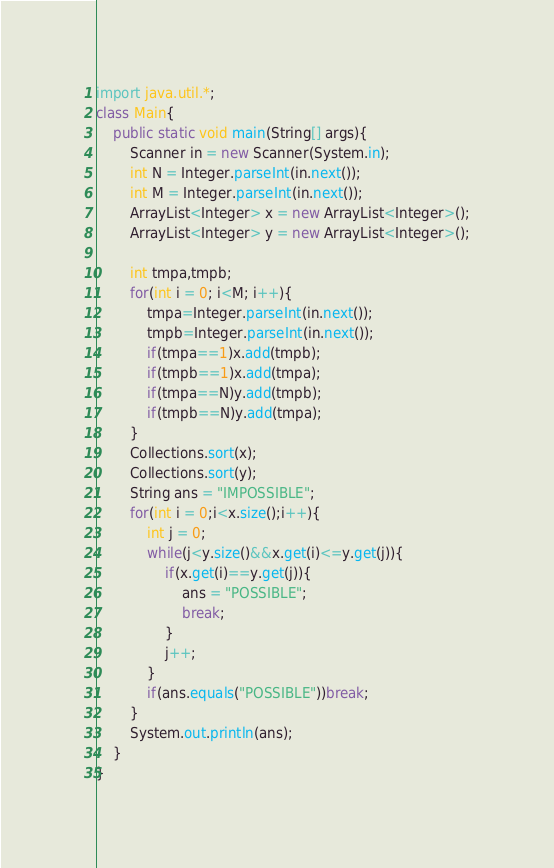Convert code to text. <code><loc_0><loc_0><loc_500><loc_500><_Java_>import java.util.*;
class Main{
	public static void main(String[] args){
		Scanner in = new Scanner(System.in);
		int N = Integer.parseInt(in.next());
		int M = Integer.parseInt(in.next());
		ArrayList<Integer> x = new ArrayList<Integer>();
		ArrayList<Integer> y = new ArrayList<Integer>();
		
		int tmpa,tmpb;
		for(int i = 0; i<M; i++){
			tmpa=Integer.parseInt(in.next());
			tmpb=Integer.parseInt(in.next());
			if(tmpa==1)x.add(tmpb);
			if(tmpb==1)x.add(tmpa);
			if(tmpa==N)y.add(tmpb);
			if(tmpb==N)y.add(tmpa);
		}
		Collections.sort(x);
		Collections.sort(y);
		String ans = "IMPOSSIBLE";
		for(int i = 0;i<x.size();i++){
			int j = 0;
			while(j<y.size()&&x.get(i)<=y.get(j)){
				if(x.get(i)==y.get(j)){
					ans = "POSSIBLE";
					break;
				}
				j++;
			}
			if(ans.equals("POSSIBLE"))break;
		}
		System.out.println(ans);
	}
}</code> 